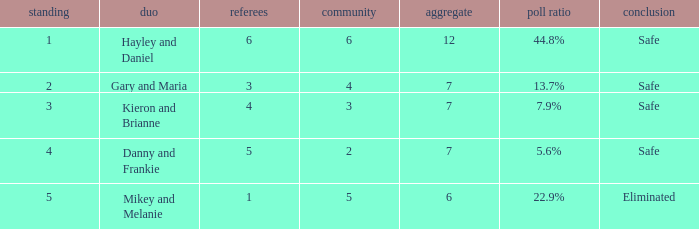How many public is there for the couple that got eliminated? 5.0. 